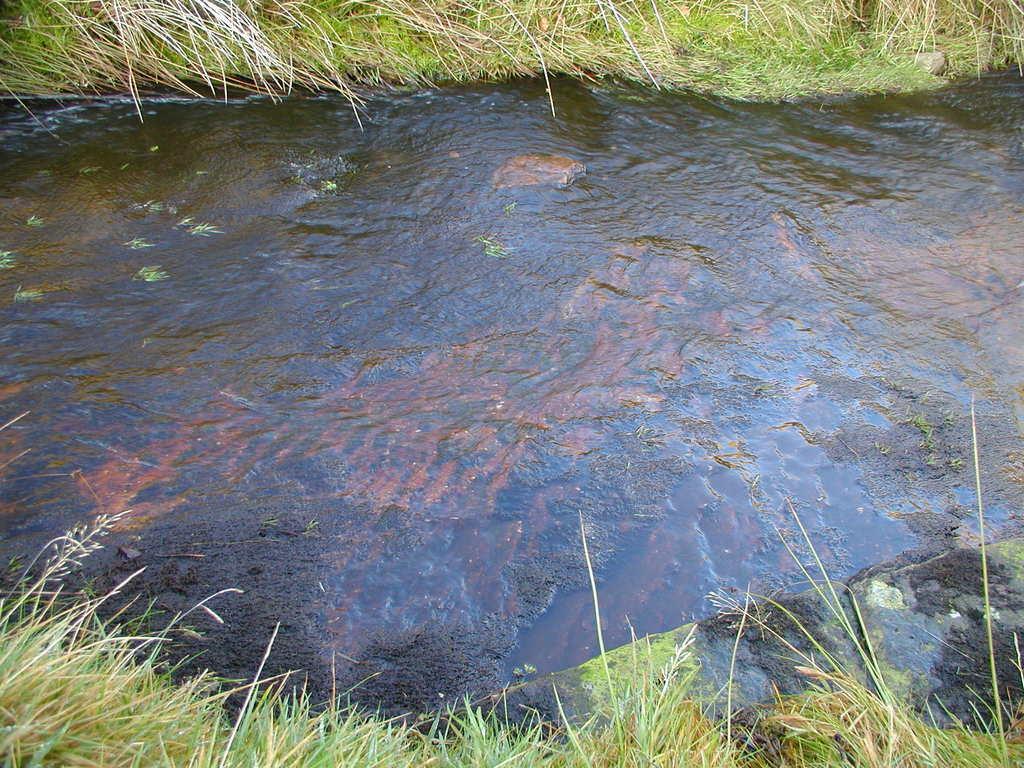Describe this image in one or two sentences. In the image there is a water surface flowing in between the grass. 